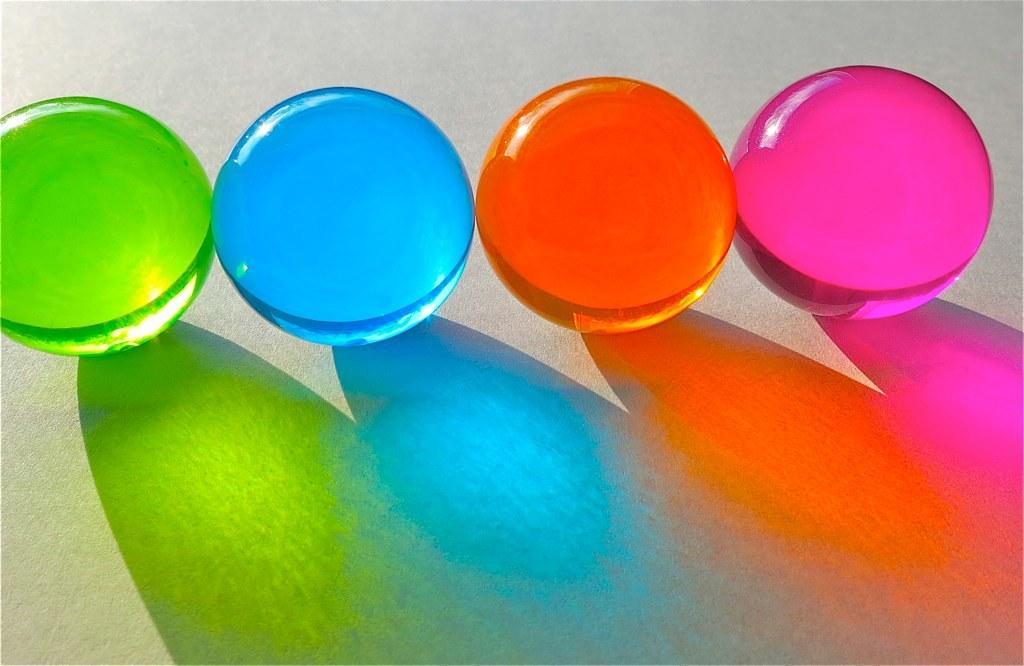In one or two sentences, can you explain what this image depicts? In this image we can see four colored balls on the surface. 